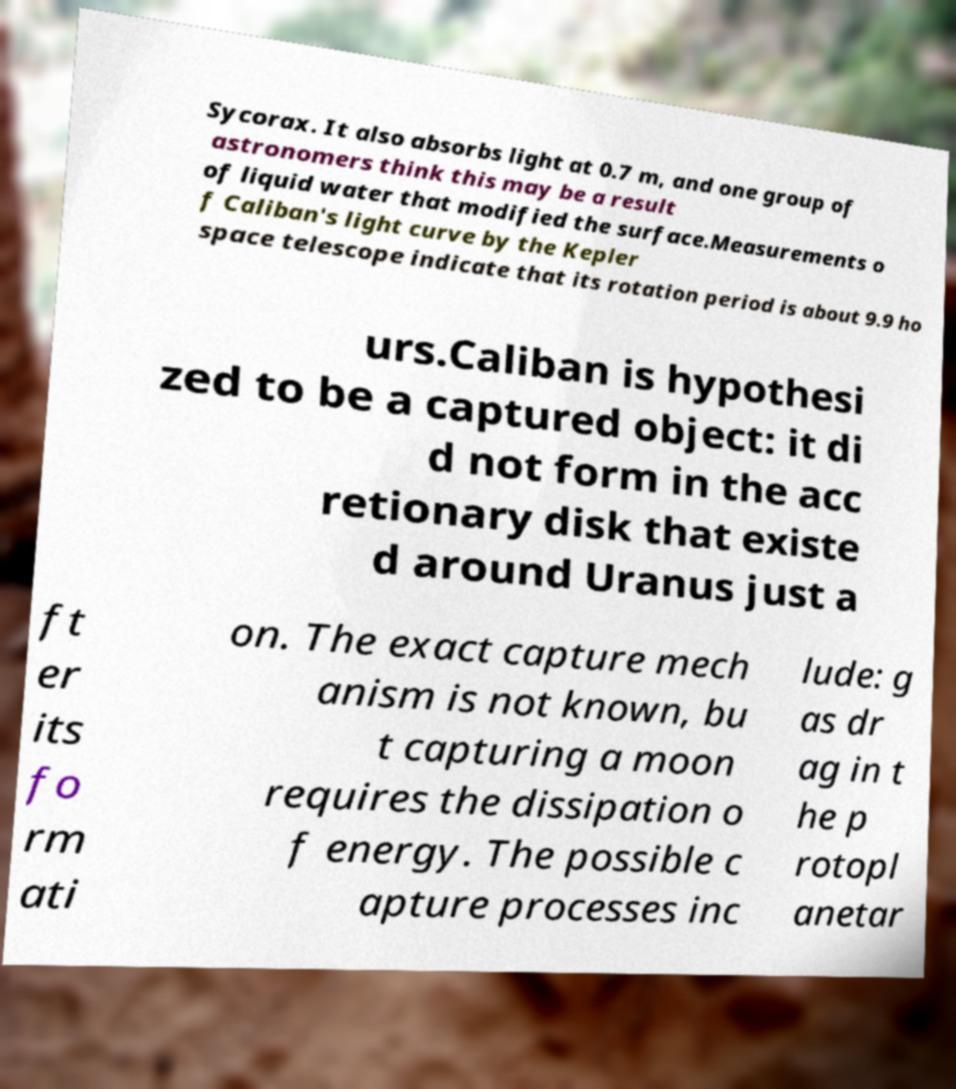I need the written content from this picture converted into text. Can you do that? Sycorax. It also absorbs light at 0.7 m, and one group of astronomers think this may be a result of liquid water that modified the surface.Measurements o f Caliban's light curve by the Kepler space telescope indicate that its rotation period is about 9.9 ho urs.Caliban is hypothesi zed to be a captured object: it di d not form in the acc retionary disk that existe d around Uranus just a ft er its fo rm ati on. The exact capture mech anism is not known, bu t capturing a moon requires the dissipation o f energy. The possible c apture processes inc lude: g as dr ag in t he p rotopl anetar 